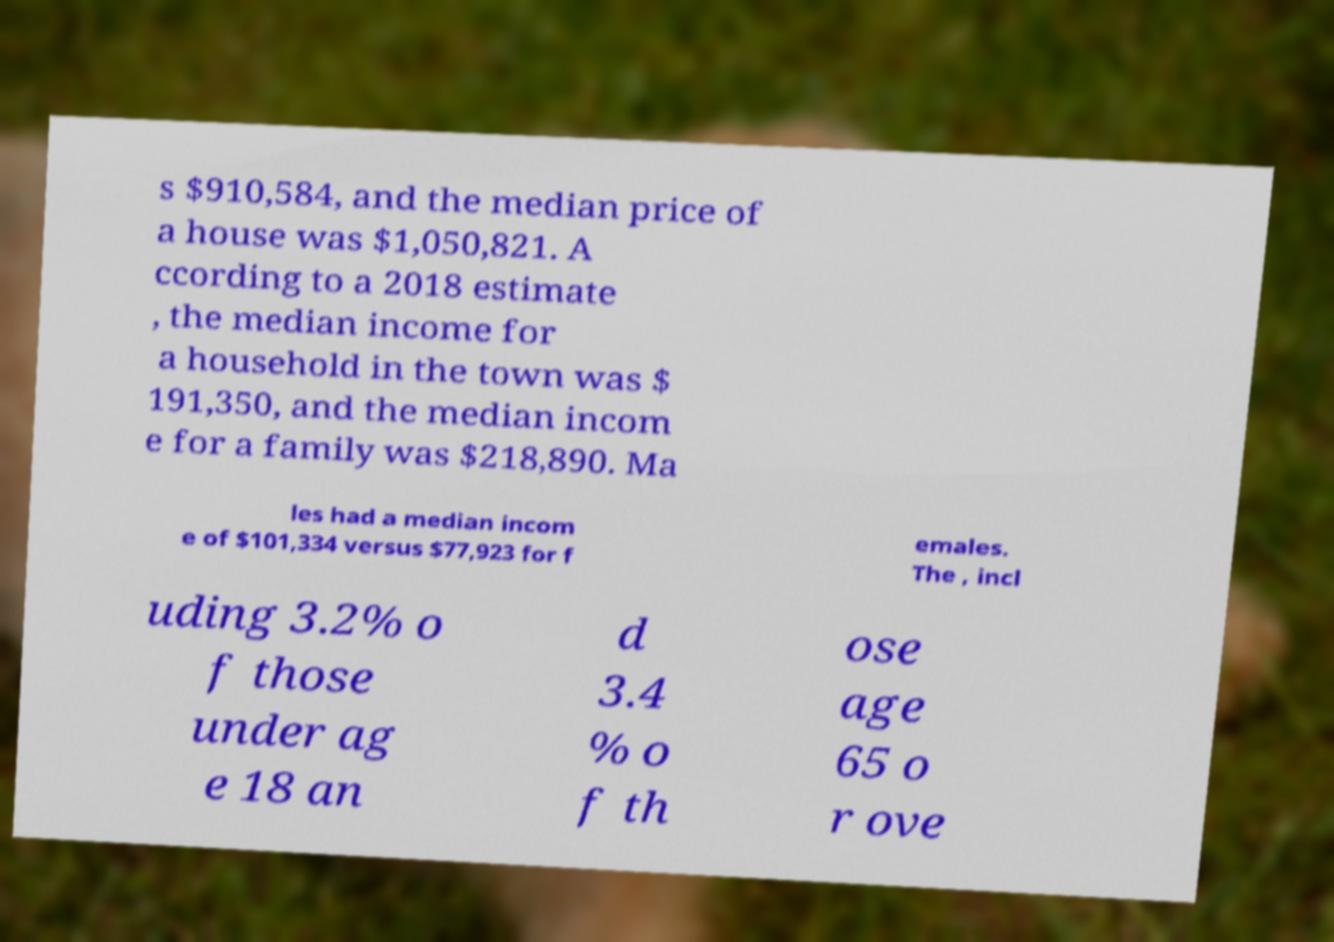Can you read and provide the text displayed in the image?This photo seems to have some interesting text. Can you extract and type it out for me? s $910,584, and the median price of a house was $1,050,821. A ccording to a 2018 estimate , the median income for a household in the town was $ 191,350, and the median incom e for a family was $218,890. Ma les had a median incom e of $101,334 versus $77,923 for f emales. The , incl uding 3.2% o f those under ag e 18 an d 3.4 % o f th ose age 65 o r ove 